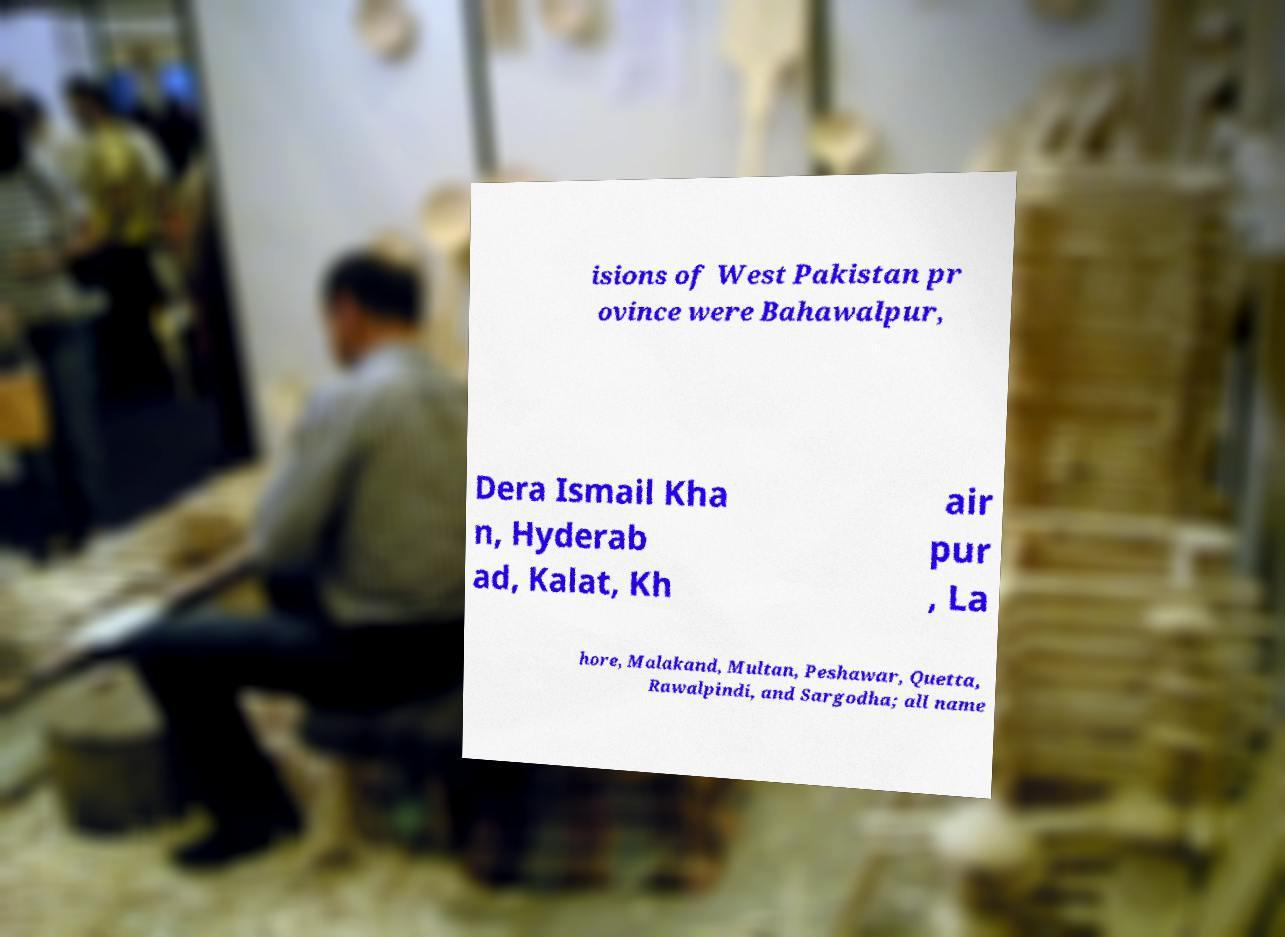Please read and relay the text visible in this image. What does it say? isions of West Pakistan pr ovince were Bahawalpur, Dera Ismail Kha n, Hyderab ad, Kalat, Kh air pur , La hore, Malakand, Multan, Peshawar, Quetta, Rawalpindi, and Sargodha; all name 